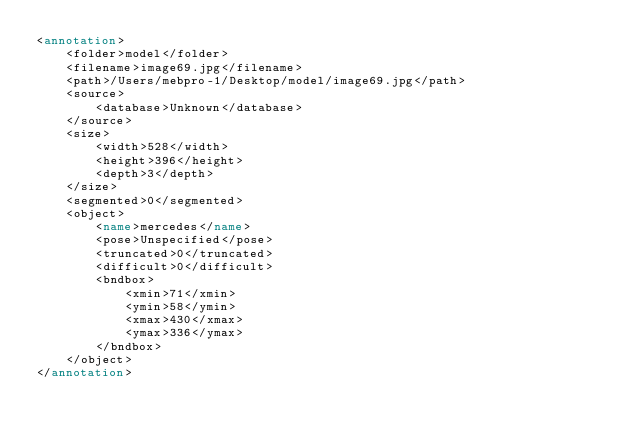<code> <loc_0><loc_0><loc_500><loc_500><_XML_><annotation>
	<folder>model</folder>
	<filename>image69.jpg</filename>
	<path>/Users/mebpro-1/Desktop/model/image69.jpg</path>
	<source>
		<database>Unknown</database>
	</source>
	<size>
		<width>528</width>
		<height>396</height>
		<depth>3</depth>
	</size>
	<segmented>0</segmented>
	<object>
		<name>mercedes</name>
		<pose>Unspecified</pose>
		<truncated>0</truncated>
		<difficult>0</difficult>
		<bndbox>
			<xmin>71</xmin>
			<ymin>58</ymin>
			<xmax>430</xmax>
			<ymax>336</ymax>
		</bndbox>
	</object>
</annotation>
</code> 